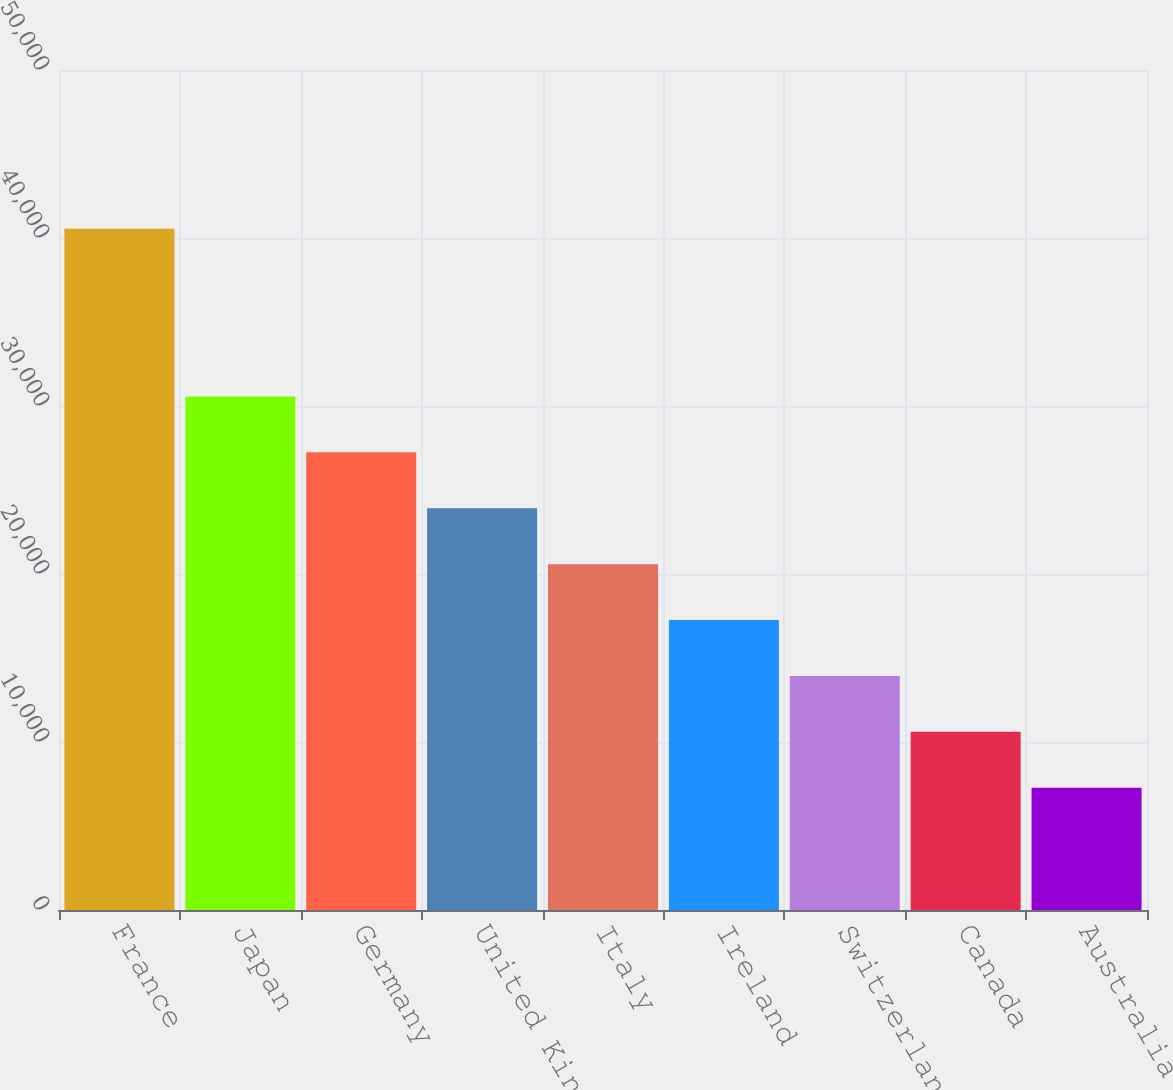Convert chart. <chart><loc_0><loc_0><loc_500><loc_500><bar_chart><fcel>France<fcel>Japan<fcel>Germany<fcel>United Kingdom<fcel>Italy<fcel>Ireland<fcel>Switzerland<fcel>Canada<fcel>Australia<nl><fcel>40551<fcel>30568.5<fcel>27241<fcel>23913.5<fcel>20586<fcel>17258.5<fcel>13931<fcel>10603.5<fcel>7276<nl></chart> 